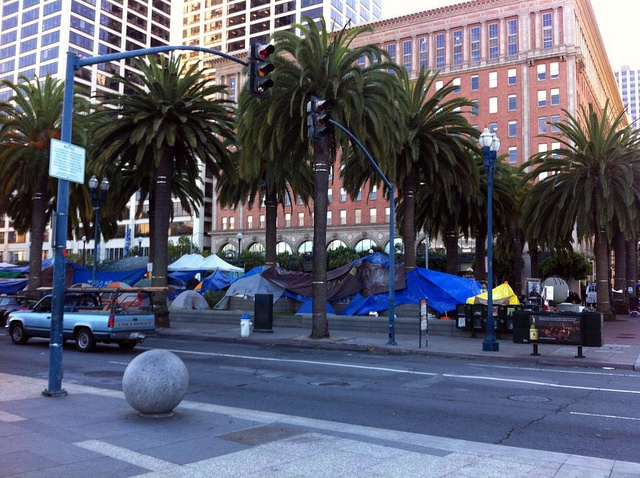Describe the objects in this image and their specific colors. I can see truck in white, black, navy, gray, and lightblue tones, traffic light in white, black, gray, and maroon tones, traffic light in white, black, gray, and darkblue tones, car in white, black, navy, and gray tones, and fire hydrant in white, lightblue, and gray tones in this image. 